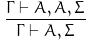Convert formula to latex. <formula><loc_0><loc_0><loc_500><loc_500>\frac { \Gamma \vdash A , A , \Sigma } { \Gamma \vdash A , \Sigma }</formula> 